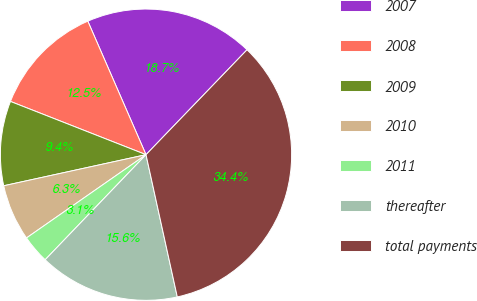Convert chart. <chart><loc_0><loc_0><loc_500><loc_500><pie_chart><fcel>2007<fcel>2008<fcel>2009<fcel>2010<fcel>2011<fcel>thereafter<fcel>total payments<nl><fcel>18.74%<fcel>12.5%<fcel>9.38%<fcel>6.26%<fcel>3.14%<fcel>15.62%<fcel>34.35%<nl></chart> 